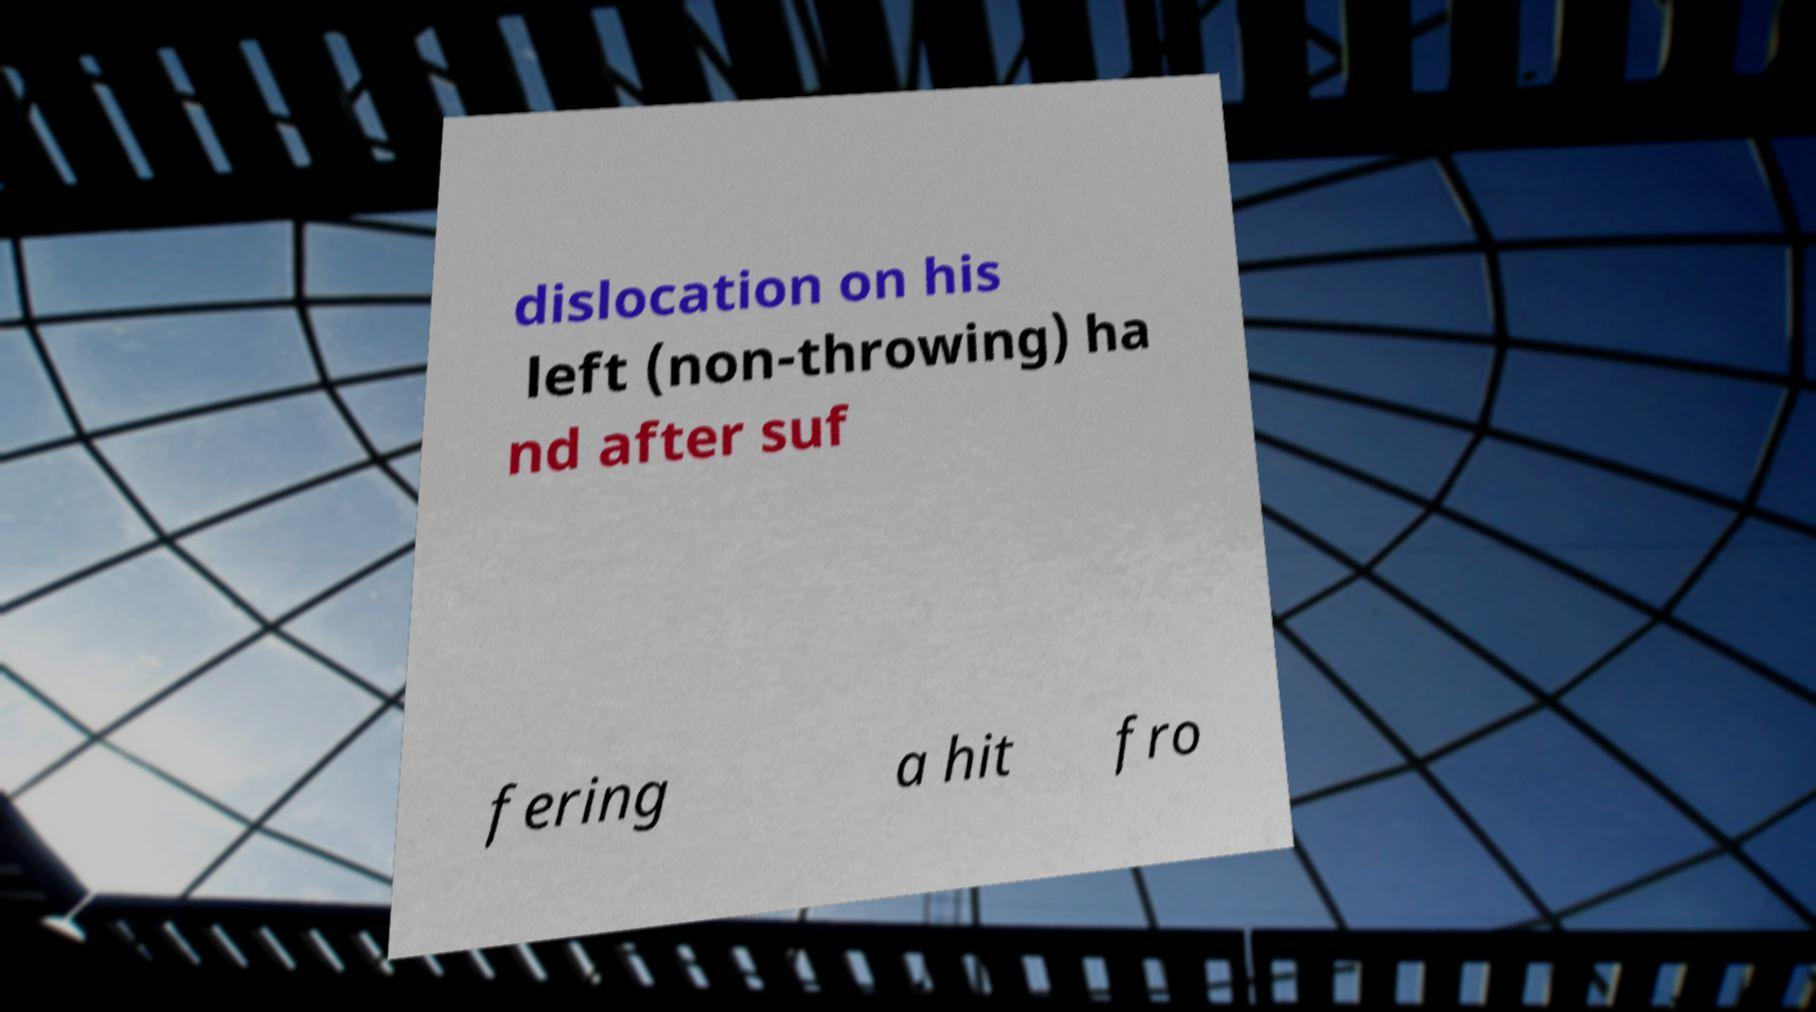There's text embedded in this image that I need extracted. Can you transcribe it verbatim? dislocation on his left (non-throwing) ha nd after suf fering a hit fro 